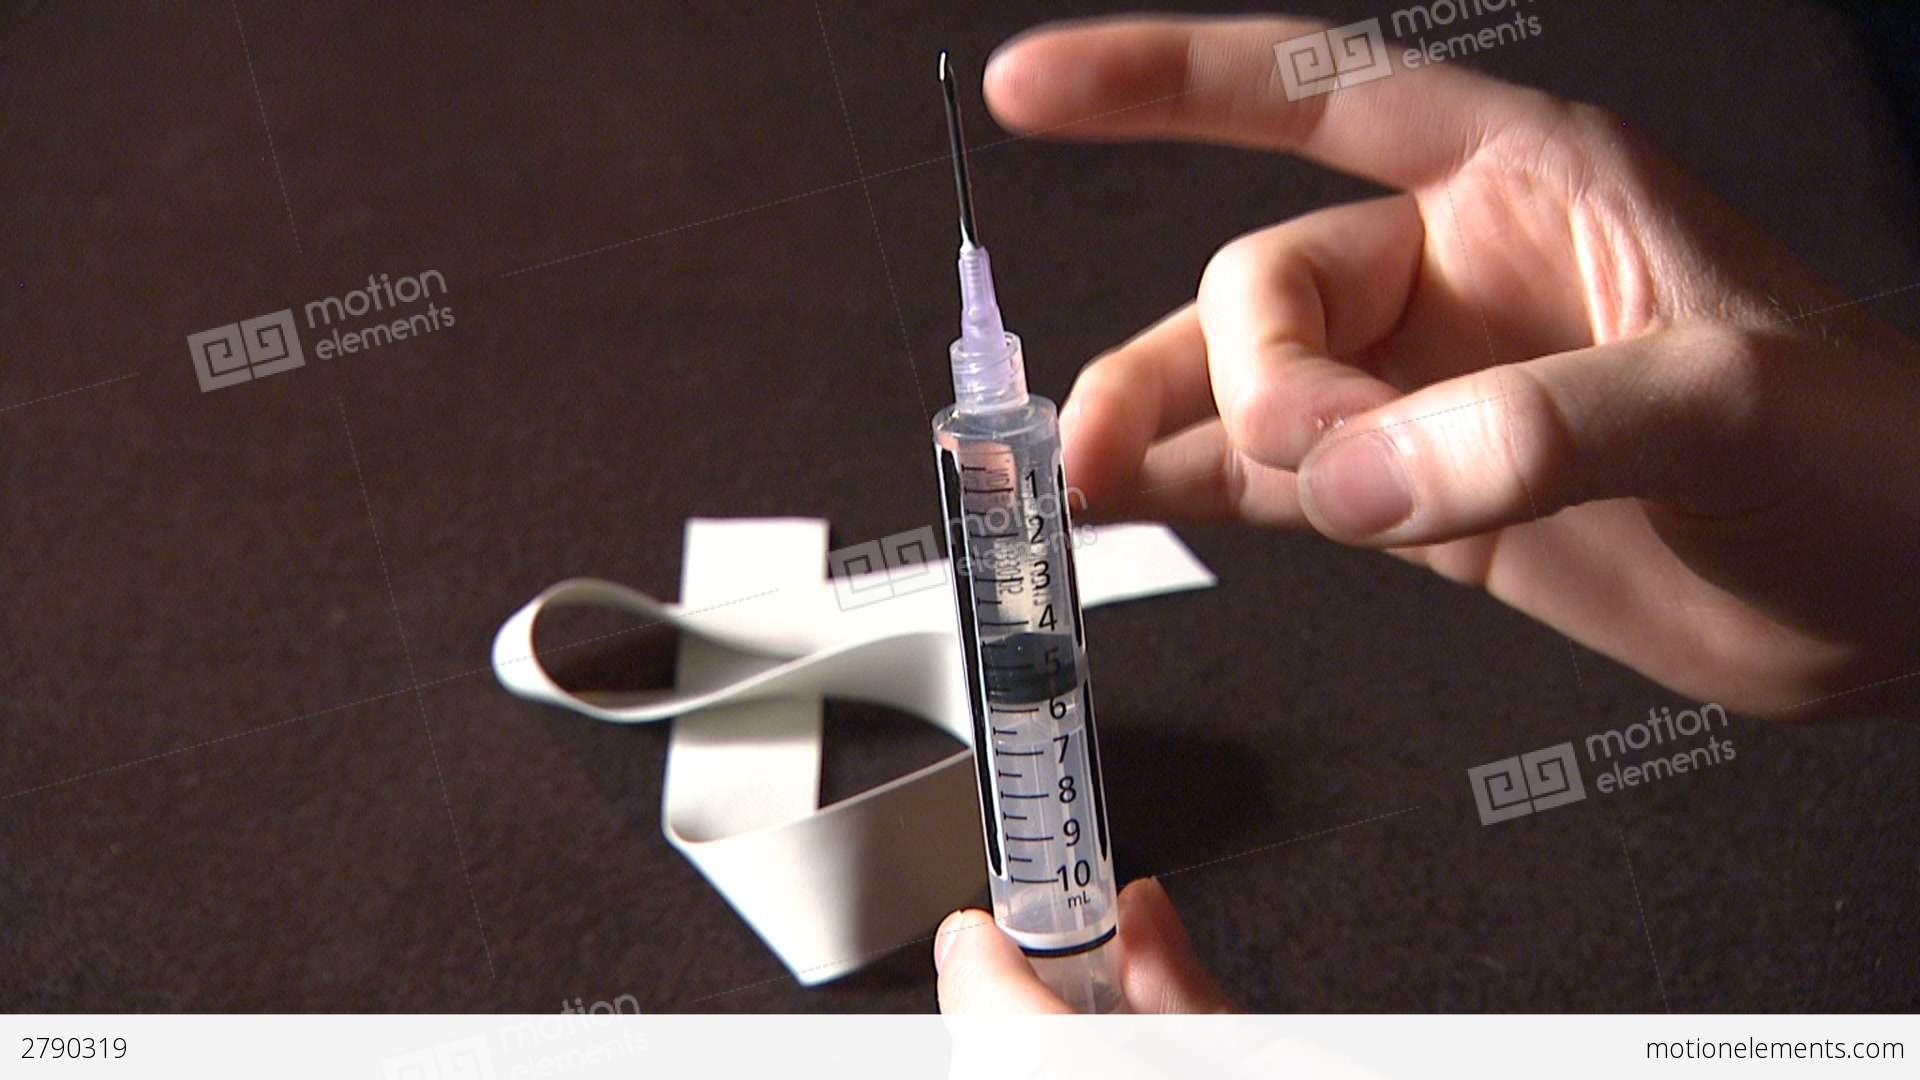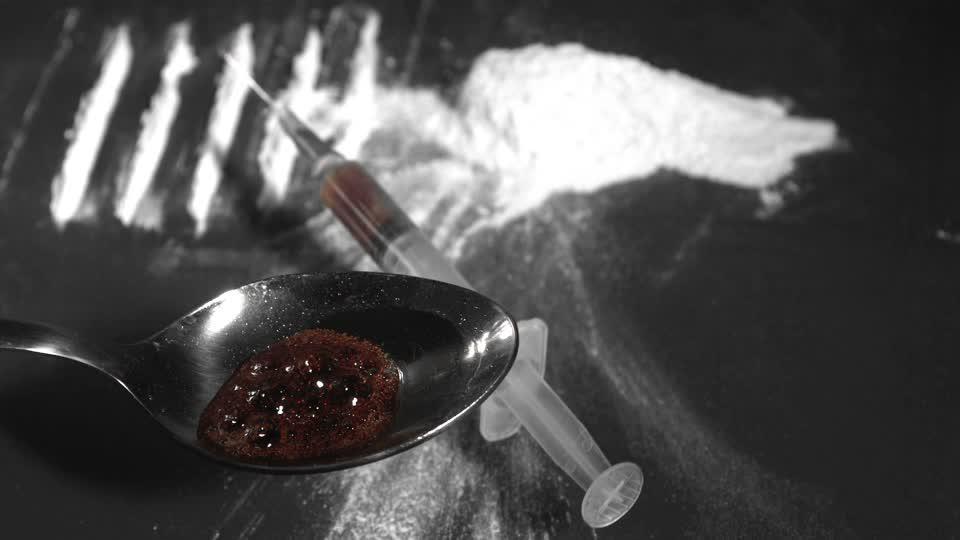The first image is the image on the left, the second image is the image on the right. For the images shown, is this caption "There are two needles and one spoon." true? Answer yes or no. Yes. The first image is the image on the left, the second image is the image on the right. Evaluate the accuracy of this statement regarding the images: "There are two syringes and one spoon.". Is it true? Answer yes or no. Yes. 